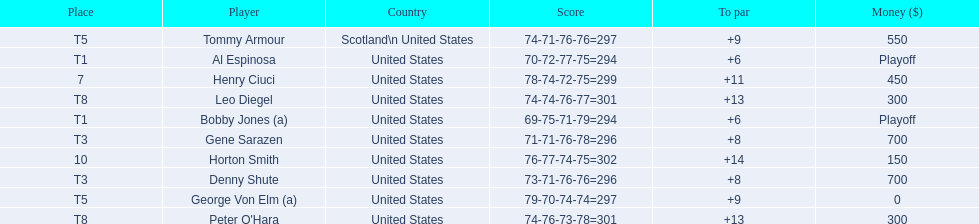Did tommy armour place above or below denny shute? Below. 